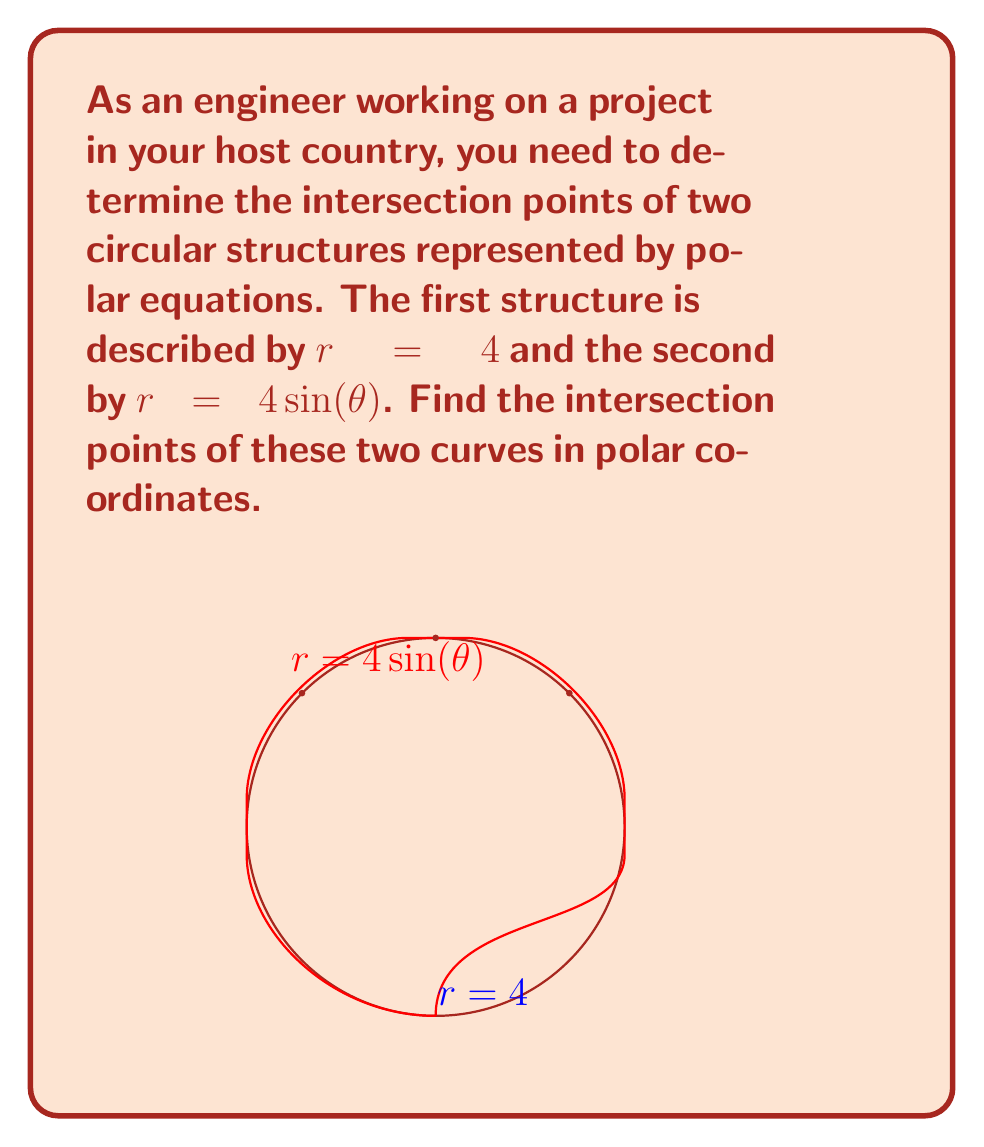Teach me how to tackle this problem. To find the intersection points, we need to solve the equation:

$$ 4 = 4\sin(\theta) $$

Step 1: Simplify the equation
$$ 1 = \sin(\theta) $$

Step 2: Solve for $\theta$
The solution to this equation is:
$$ \theta = \frac{\pi}{2} + 2\pi n \quad \text{or} \quad \theta = \frac{\pi}{2} - \frac{\pi}{2} + 2\pi n = 2\pi n $$
where $n$ is an integer.

Step 3: Consider the domain of $\sin(\theta)$
Since $\sin(\theta)$ is periodic with period $2\pi$, we only need to consider $n = 0$ for the first solution.

Step 4: Calculate $r$ for each $\theta$
For $\theta = \frac{\pi}{2}$: $r = 4$
For $\theta = 0$: $r = 0$ (this is not on the circle $r = 4$)

Step 5: Convert to Cartesian coordinates (optional, for visualization)
$(\frac{\pi}{2}, 4)$ in polar coordinates is equivalent to $(0, 4)$ in Cartesian coordinates.

Therefore, the intersection point is $(\frac{\pi}{2}, 4)$ in polar coordinates.
Answer: $(\frac{\pi}{2}, 4)$ 